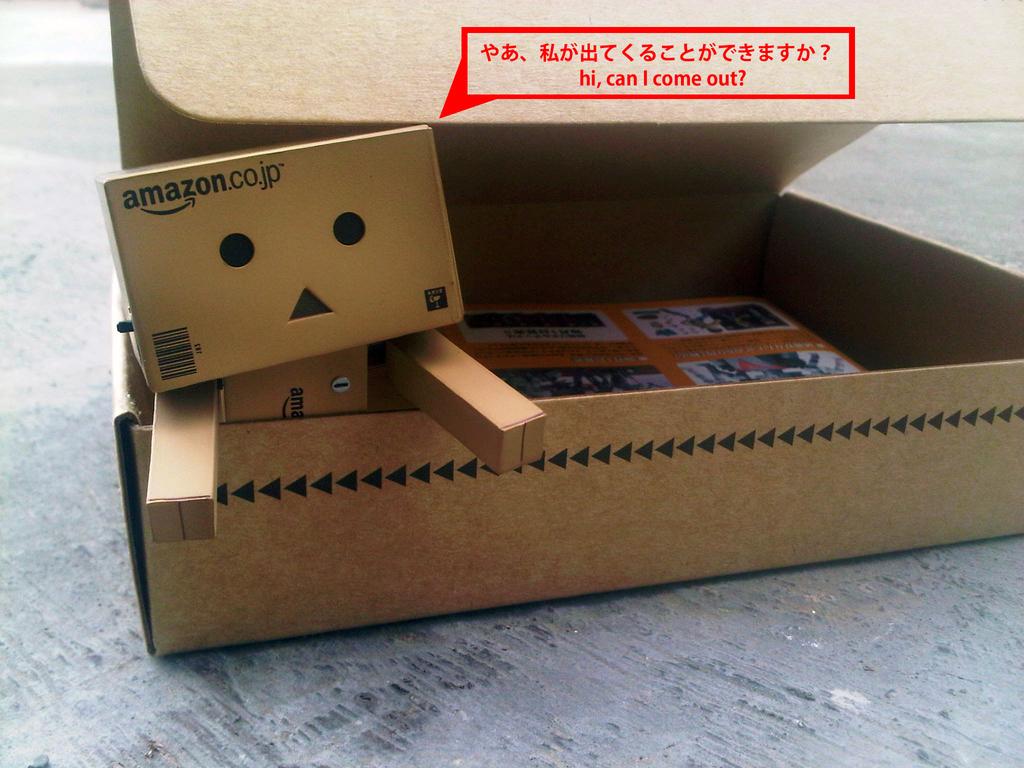What company is the box from?
Your response must be concise. Amazon. 